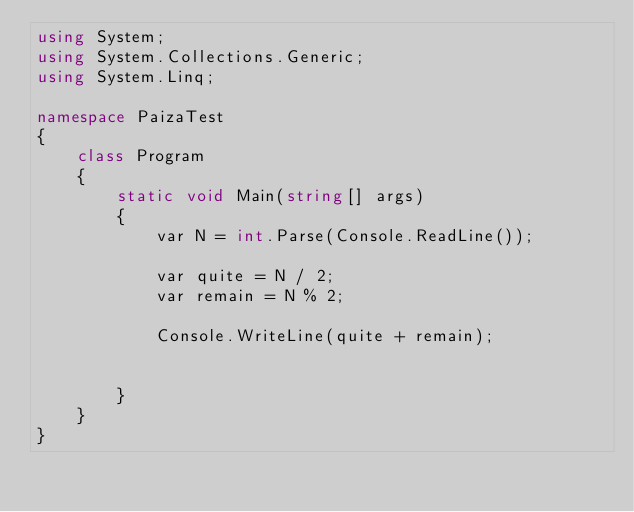<code> <loc_0><loc_0><loc_500><loc_500><_C#_>using System;
using System.Collections.Generic;
using System.Linq;

namespace PaizaTest
{
    class Program
    {
        static void Main(string[] args)
        {
            var N = int.Parse(Console.ReadLine());

            var quite = N / 2;
            var remain = N % 2;

            Console.WriteLine(quite + remain);


        }
    }
}
</code> 